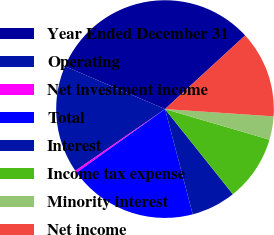Convert chart to OTSL. <chart><loc_0><loc_0><loc_500><loc_500><pie_chart><fcel>Year Ended December 31<fcel>Operating<fcel>Net investment income<fcel>Total<fcel>Interest<fcel>Income tax expense<fcel>Minority interest<fcel>Net income<nl><fcel>31.73%<fcel>16.03%<fcel>0.33%<fcel>19.17%<fcel>6.61%<fcel>9.75%<fcel>3.47%<fcel>12.89%<nl></chart> 